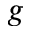<formula> <loc_0><loc_0><loc_500><loc_500>g</formula> 